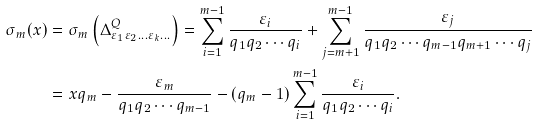Convert formula to latex. <formula><loc_0><loc_0><loc_500><loc_500>\sigma _ { m } ( x ) & = \sigma _ { m } \left ( \Delta ^ { Q } _ { \varepsilon _ { 1 } \varepsilon _ { 2 } \dots \varepsilon _ { k } \dots } \right ) = \sum ^ { m - 1 } _ { i = 1 } { \frac { \varepsilon _ { i } } { q _ { 1 } q _ { 2 } \cdots q _ { i } } } + \sum ^ { m - 1 } _ { j = m + 1 } { \frac { \varepsilon _ { j } } { q _ { 1 } q _ { 2 } \cdots q _ { m - 1 } q _ { m + 1 } \cdots q _ { j } } } \\ & = x q _ { m } - \frac { \varepsilon _ { m } } { q _ { 1 } q _ { 2 } \cdots q _ { m - 1 } } - ( q _ { m } - 1 ) \sum ^ { m - 1 } _ { i = 1 } { \frac { \varepsilon _ { i } } { q _ { 1 } q _ { 2 } \cdots q _ { i } } } .</formula> 